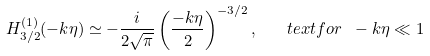<formula> <loc_0><loc_0><loc_500><loc_500>H _ { 3 / 2 } ^ { ( 1 ) } ( - k \eta ) \simeq - \frac { i } { 2 \sqrt { \pi } } \left ( \frac { - k \eta } { 2 } \right ) ^ { - 3 / 2 } , \quad t e x t { f o r } \ - k \eta \ll 1</formula> 